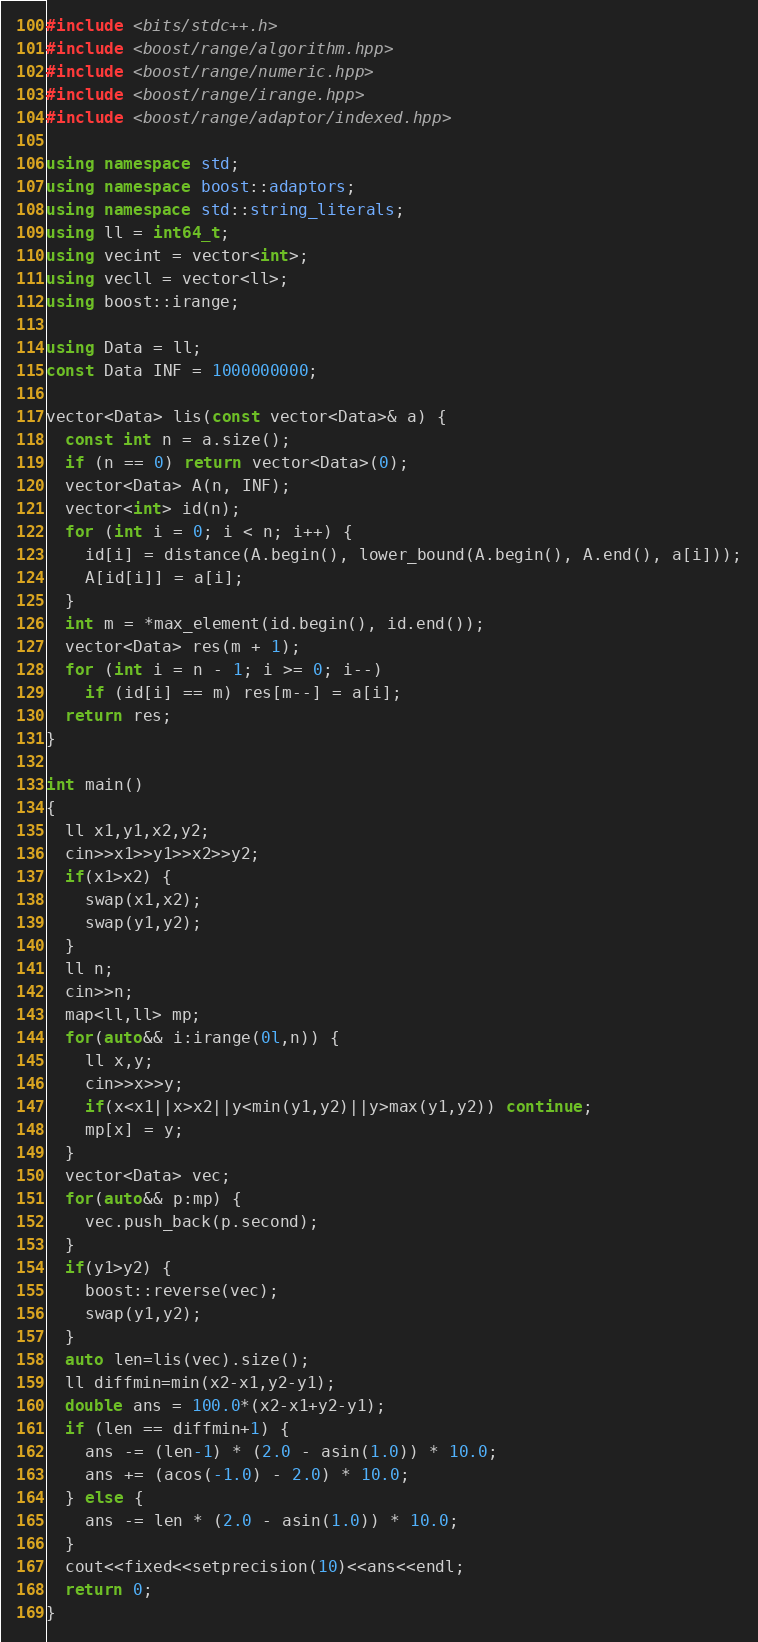<code> <loc_0><loc_0><loc_500><loc_500><_C++_>#include <bits/stdc++.h>
#include <boost/range/algorithm.hpp>
#include <boost/range/numeric.hpp>
#include <boost/range/irange.hpp>
#include <boost/range/adaptor/indexed.hpp>

using namespace std;
using namespace boost::adaptors;
using namespace std::string_literals;
using ll = int64_t;
using vecint = vector<int>;
using vecll = vector<ll>;
using boost::irange;

using Data = ll;
const Data INF = 1000000000;

vector<Data> lis(const vector<Data>& a) {
  const int n = a.size();
  if (n == 0) return vector<Data>(0);
  vector<Data> A(n, INF);
  vector<int> id(n);
  for (int i = 0; i < n; i++) {
    id[i] = distance(A.begin(), lower_bound(A.begin(), A.end(), a[i]));
    A[id[i]] = a[i];
  }
  int m = *max_element(id.begin(), id.end());
  vector<Data> res(m + 1);
  for (int i = n - 1; i >= 0; i--)
    if (id[i] == m) res[m--] = a[i];
  return res;
}

int main()
{
  ll x1,y1,x2,y2;
  cin>>x1>>y1>>x2>>y2;
  if(x1>x2) {
    swap(x1,x2);
    swap(y1,y2);
  }
  ll n;
  cin>>n;
  map<ll,ll> mp;
  for(auto&& i:irange(0l,n)) {
    ll x,y;
    cin>>x>>y;
    if(x<x1||x>x2||y<min(y1,y2)||y>max(y1,y2)) continue;
    mp[x] = y;
  }
  vector<Data> vec;
  for(auto&& p:mp) {
    vec.push_back(p.second);
  }
  if(y1>y2) {
    boost::reverse(vec);
    swap(y1,y2);
  }
  auto len=lis(vec).size();
  ll diffmin=min(x2-x1,y2-y1);
  double ans = 100.0*(x2-x1+y2-y1);
  if (len == diffmin+1) {
    ans -= (len-1) * (2.0 - asin(1.0)) * 10.0;
    ans += (acos(-1.0) - 2.0) * 10.0;
  } else {
    ans -= len * (2.0 - asin(1.0)) * 10.0;
  }
  cout<<fixed<<setprecision(10)<<ans<<endl;
  return 0;
}
</code> 